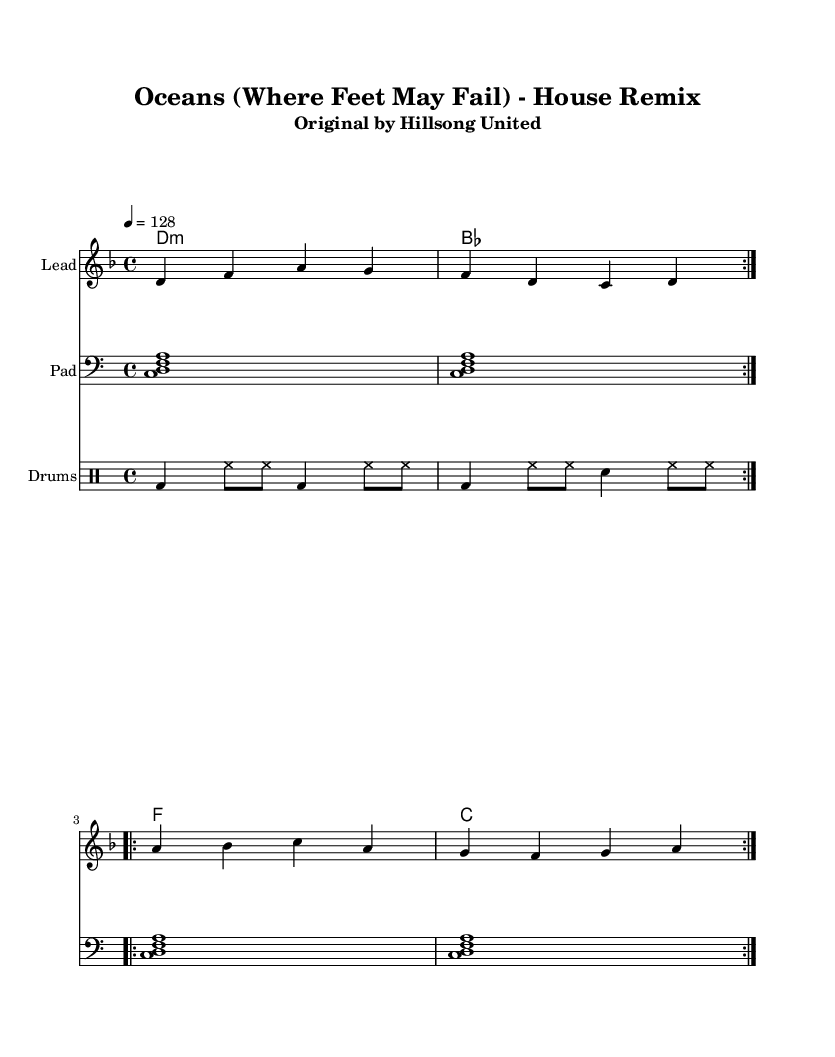What is the key signature of this music? The key signature is D minor, which contains one flat (B-flat). This can be identified in the sheet music where a flat sign is placed on the B line, indicating that all B notes should be played as B-flat.
Answer: D minor What is the time signature of this music? The time signature is 4/4, which indicates that there are four beats in each measure and a quarter note receives one beat. This is shown at the beginning of the sheet music next to the key signature.
Answer: 4/4 What is the tempo marking of this music? The tempo marking is 128 beats per minute (BPM), as indicated at the top of the score. This informs the performer of the speed at which the piece should be played.
Answer: 128 How many measures are in the melody section? The melody section consists of 8 measures. This can be determined by counting the groups of four beats (4/4 time) and identifying that each section and repeat contributes to a total of 8 measures.
Answer: 8 What type of drum pattern is used in this remix? The drum pattern is a traditional house beat, characterized by a kick drum on the downbeat and hi-hats played on the off-beats. This is evident in the drum staff where the kick and hi-hat notations are visually displayed.
Answer: House beat How many times is the first section of the melody repeated? The first section of the melody is repeated twice, indicated by the volta markings (repeat signs with the number 2). This shows that the musician should play that section two times before moving on.
Answer: 2 What is the harmony chord progression used in this piece? The harmony chord progression is D minor, B-flat, F, C. This sequence is visible in the chord names placed above the melody, which outline the changing chords as the piece progresses.
Answer: D minor, B-flat, F, C 